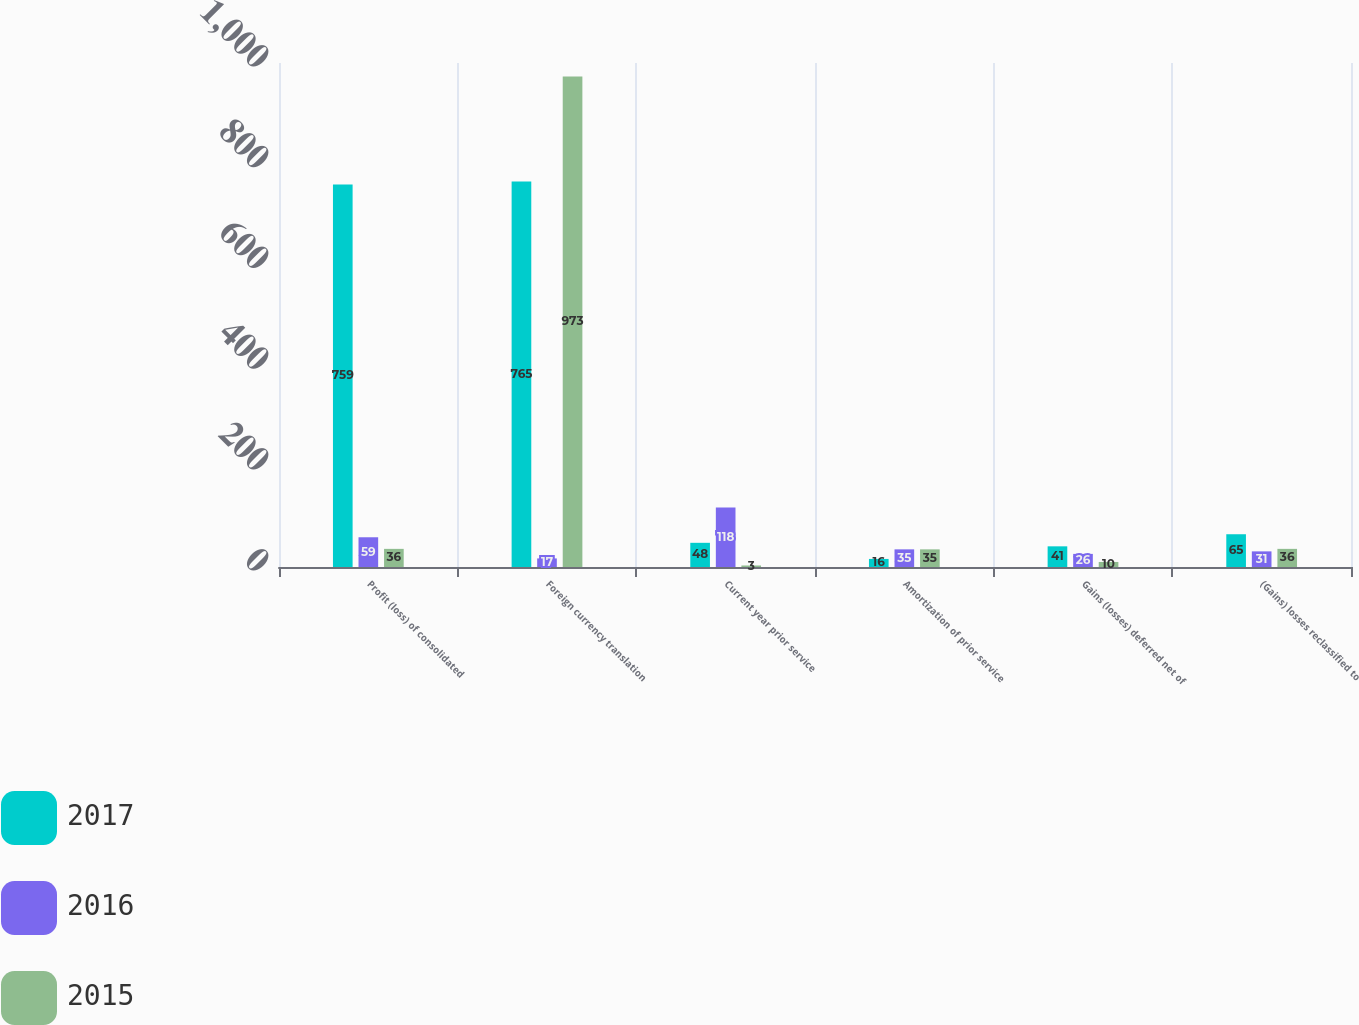<chart> <loc_0><loc_0><loc_500><loc_500><stacked_bar_chart><ecel><fcel>Profit (loss) of consolidated<fcel>Foreign currency translation<fcel>Current year prior service<fcel>Amortization of prior service<fcel>Gains (losses) deferred net of<fcel>(Gains) losses reclassified to<nl><fcel>2017<fcel>759<fcel>765<fcel>48<fcel>16<fcel>41<fcel>65<nl><fcel>2016<fcel>59<fcel>17<fcel>118<fcel>35<fcel>26<fcel>31<nl><fcel>2015<fcel>36<fcel>973<fcel>3<fcel>35<fcel>10<fcel>36<nl></chart> 